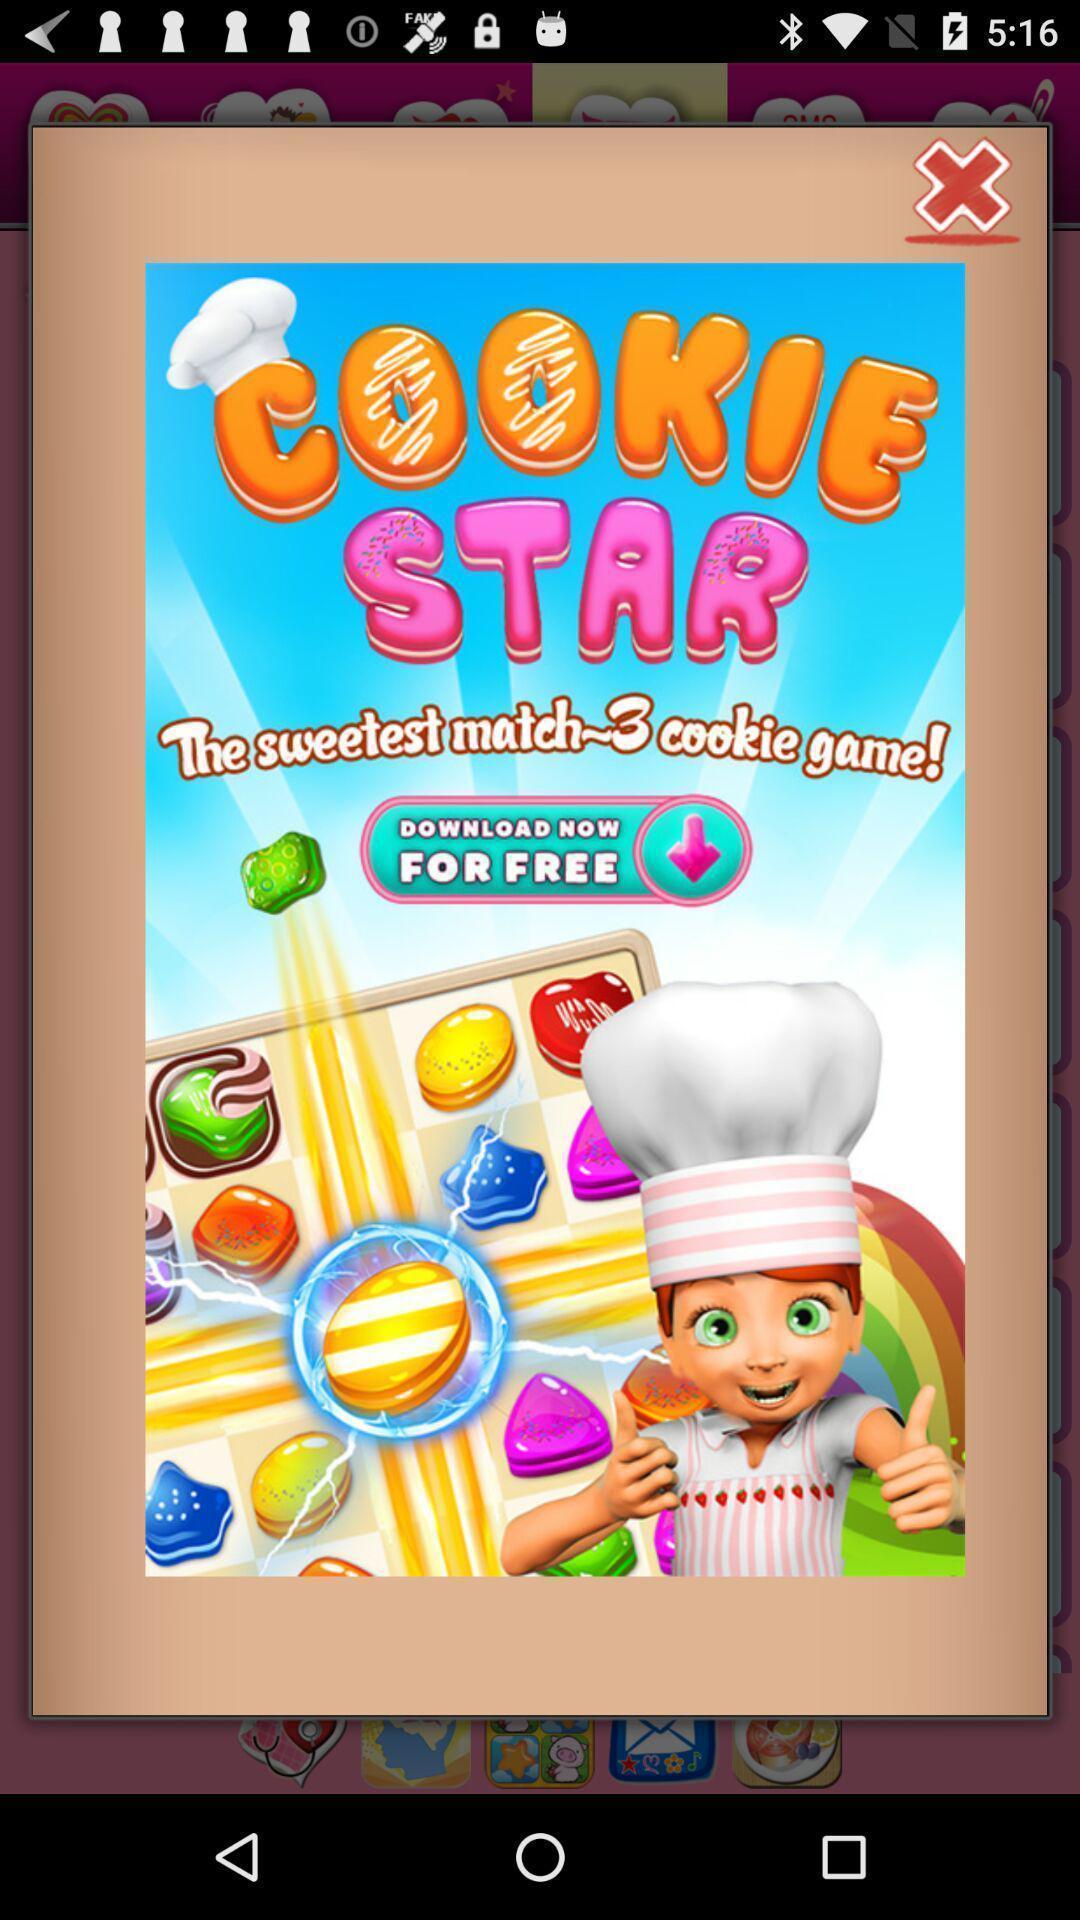Explain what's happening in this screen capture. Pop up showing cooking game application. 